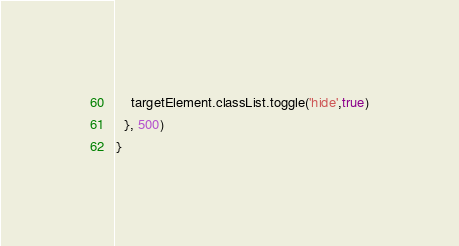<code> <loc_0><loc_0><loc_500><loc_500><_JavaScript_>    targetElement.classList.toggle('hide',true)
  }, 500)
}
</code> 